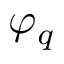Convert formula to latex. <formula><loc_0><loc_0><loc_500><loc_500>\varphi _ { q }</formula> 